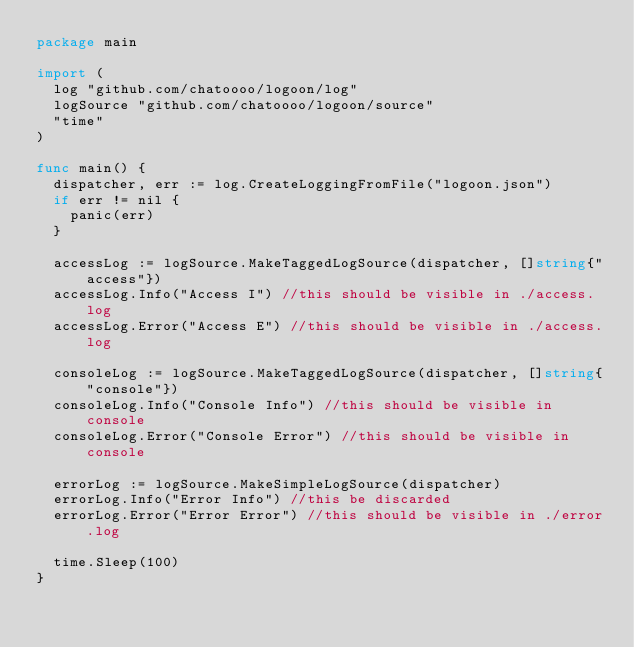<code> <loc_0><loc_0><loc_500><loc_500><_Go_>package main

import (
	log "github.com/chatoooo/logoon/log"
	logSource "github.com/chatoooo/logoon/source"
	"time"
)

func main() {
	dispatcher, err := log.CreateLoggingFromFile("logoon.json")
	if err != nil {
		panic(err)
	}

	accessLog := logSource.MakeTaggedLogSource(dispatcher, []string{"access"})
	accessLog.Info("Access I") //this should be visible in ./access.log
	accessLog.Error("Access E") //this should be visible in ./access.log

	consoleLog := logSource.MakeTaggedLogSource(dispatcher, []string{"console"})
	consoleLog.Info("Console Info") //this should be visible in console
	consoleLog.Error("Console Error") //this should be visible in console

	errorLog := logSource.MakeSimpleLogSource(dispatcher)
	errorLog.Info("Error Info") //this be discarded
	errorLog.Error("Error Error") //this should be visible in ./error.log

	time.Sleep(100)
}
</code> 